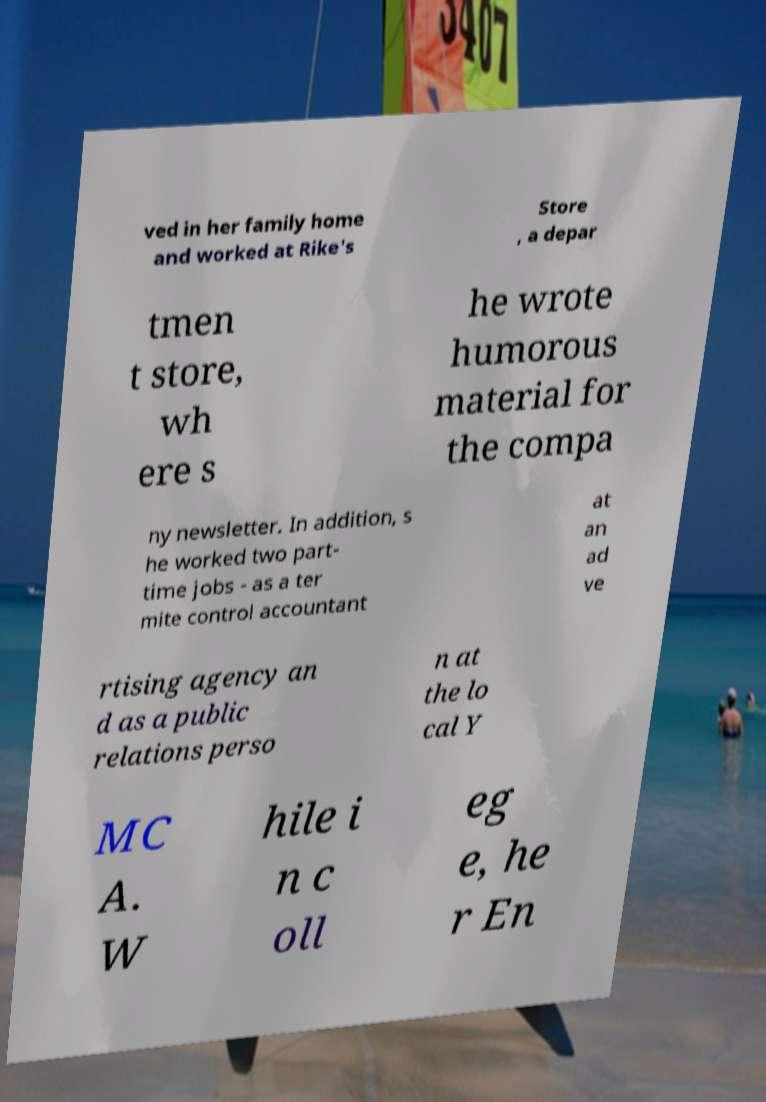I need the written content from this picture converted into text. Can you do that? ved in her family home and worked at Rike's Store , a depar tmen t store, wh ere s he wrote humorous material for the compa ny newsletter. In addition, s he worked two part- time jobs - as a ter mite control accountant at an ad ve rtising agency an d as a public relations perso n at the lo cal Y MC A. W hile i n c oll eg e, he r En 